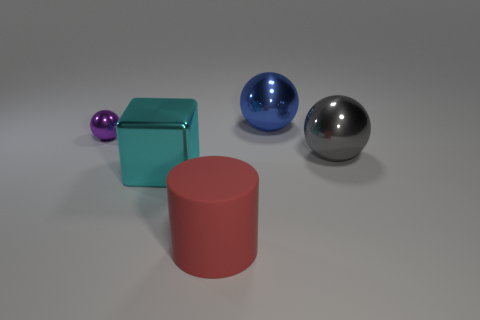Add 4 tiny cyan matte blocks. How many objects exist? 9 Subtract all purple balls. How many balls are left? 2 Subtract all large gray spheres. How many spheres are left? 2 Subtract all spheres. How many objects are left? 2 Subtract 1 balls. How many balls are left? 2 Subtract all gray cylinders. Subtract all brown cubes. How many cylinders are left? 1 Subtract all red spheres. How many gray blocks are left? 0 Subtract all large green cubes. Subtract all small purple metal spheres. How many objects are left? 4 Add 5 large cylinders. How many large cylinders are left? 6 Add 1 tiny purple metal things. How many tiny purple metal things exist? 2 